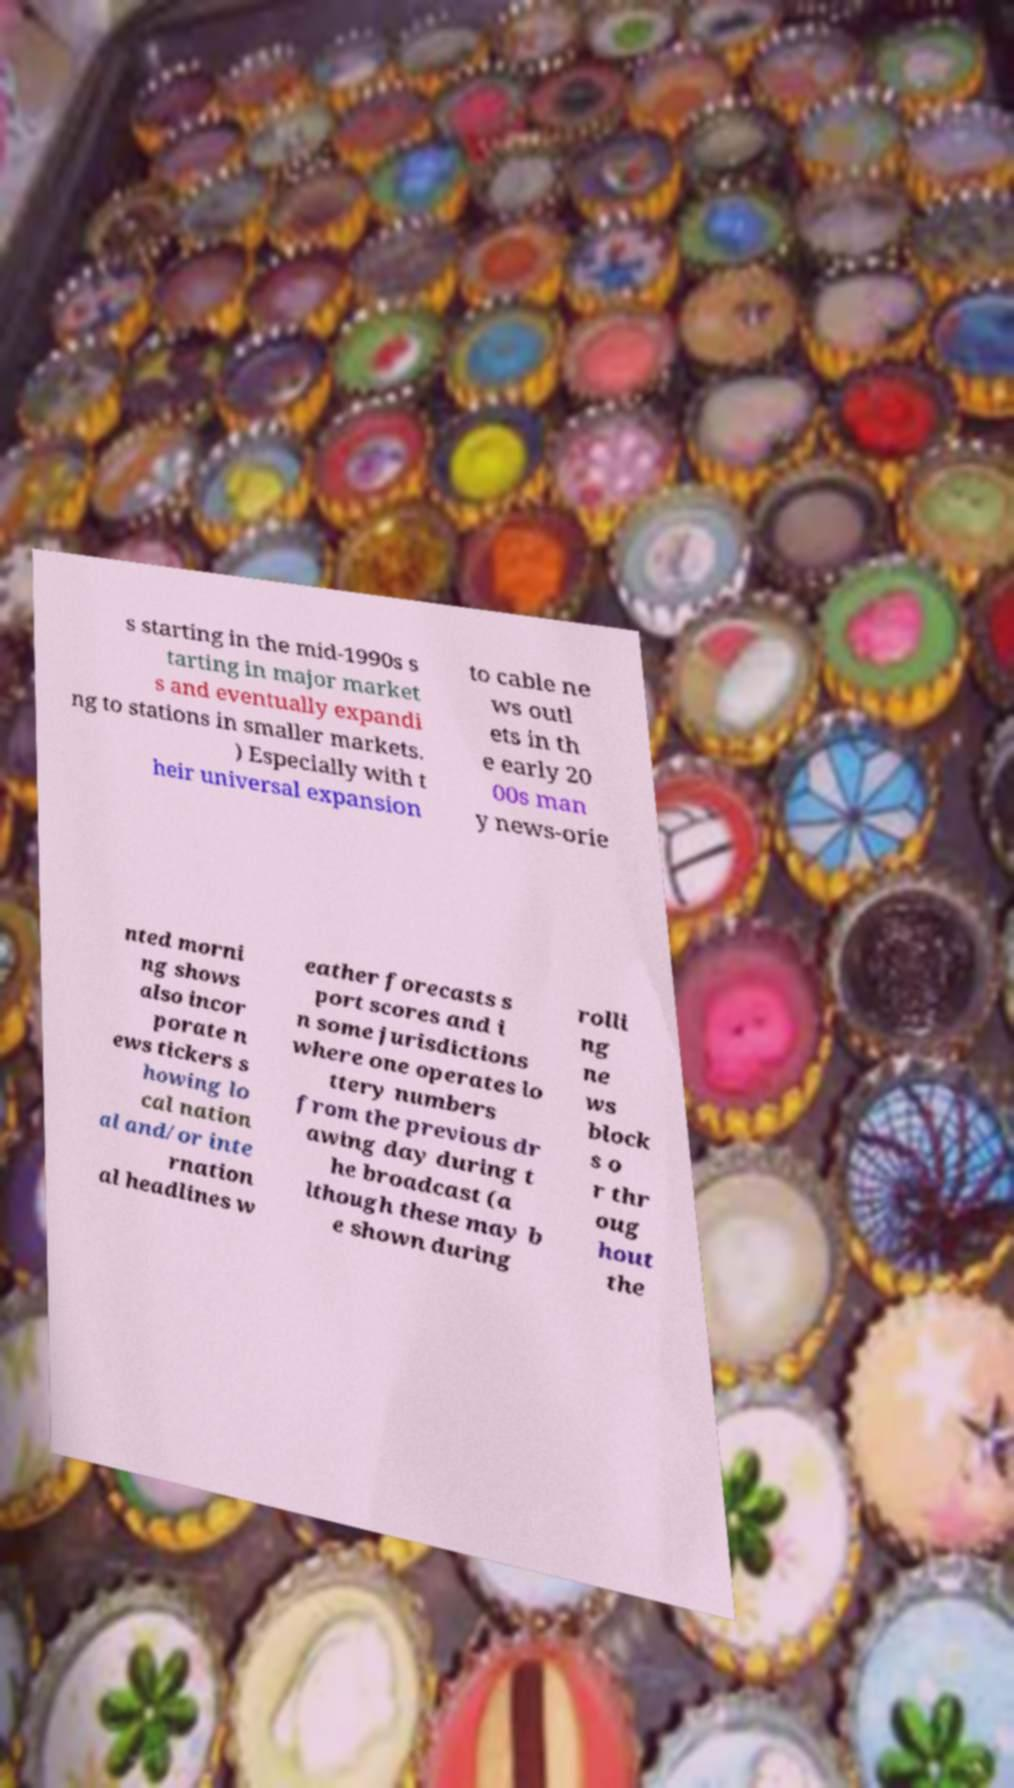Please read and relay the text visible in this image. What does it say? s starting in the mid-1990s s tarting in major market s and eventually expandi ng to stations in smaller markets. ) Especially with t heir universal expansion to cable ne ws outl ets in th e early 20 00s man y news-orie nted morni ng shows also incor porate n ews tickers s howing lo cal nation al and/or inte rnation al headlines w eather forecasts s port scores and i n some jurisdictions where one operates lo ttery numbers from the previous dr awing day during t he broadcast (a lthough these may b e shown during rolli ng ne ws block s o r thr oug hout the 